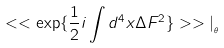<formula> <loc_0><loc_0><loc_500><loc_500>< < \exp \{ \frac { 1 } { 2 } i \int d ^ { 4 } x \Delta F ^ { 2 } \} > > | _ { _ { \theta } }</formula> 